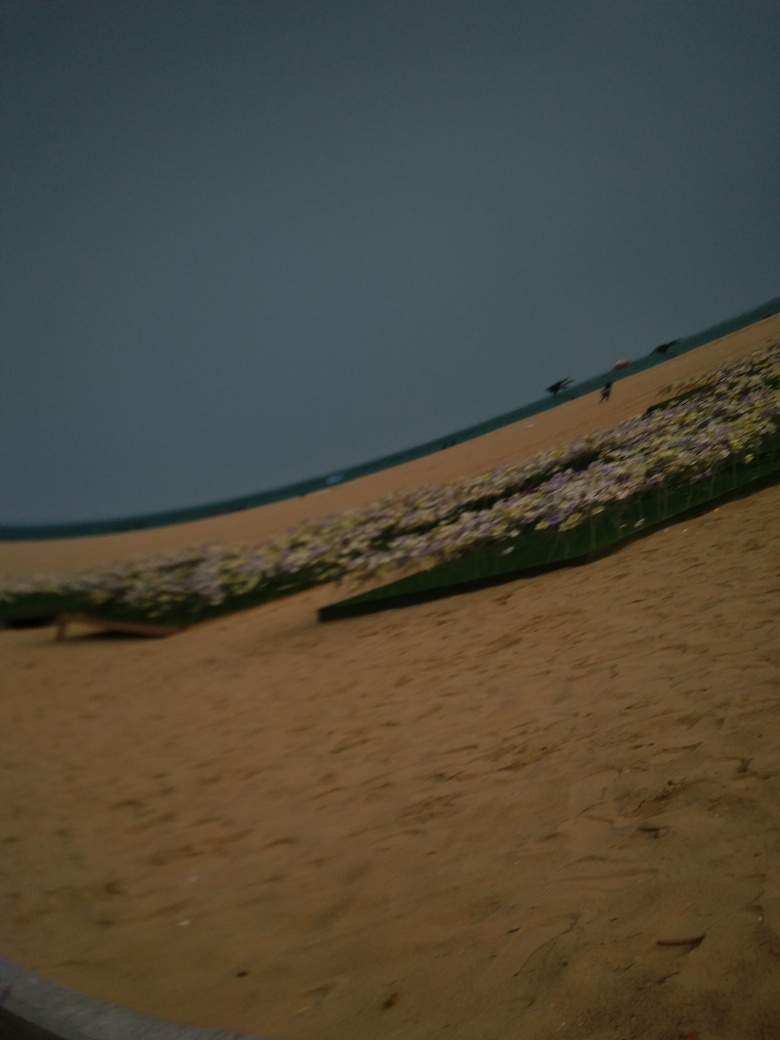Can you tell what kind of weather it might be in the image? The overcast sky and the subdued lighting suggest that it could be an overcast or cloudy day. The atmosphere is quite hazy, which might indicate humidity or mist in the air, but without additional context, it's challenging to make an accurate assessment. 